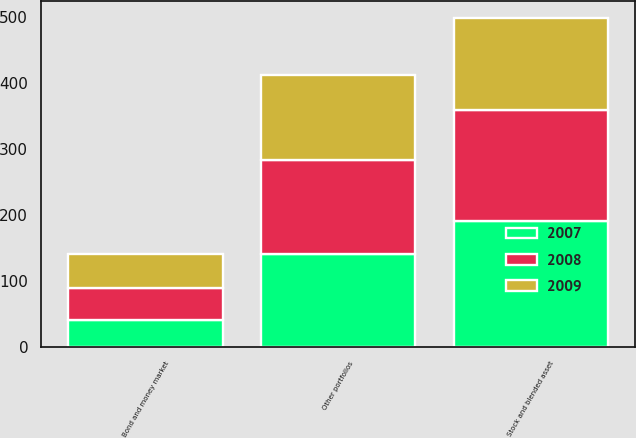Convert chart. <chart><loc_0><loc_0><loc_500><loc_500><stacked_bar_chart><ecel><fcel>Stock and blended asset<fcel>Bond and money market<fcel>Other portfolios<nl><fcel>2007<fcel>191.1<fcel>41.7<fcel>141.4<nl><fcel>2008<fcel>168.6<fcel>47.5<fcel>142.1<nl><fcel>2009<fcel>139.5<fcel>52.3<fcel>129.5<nl></chart> 